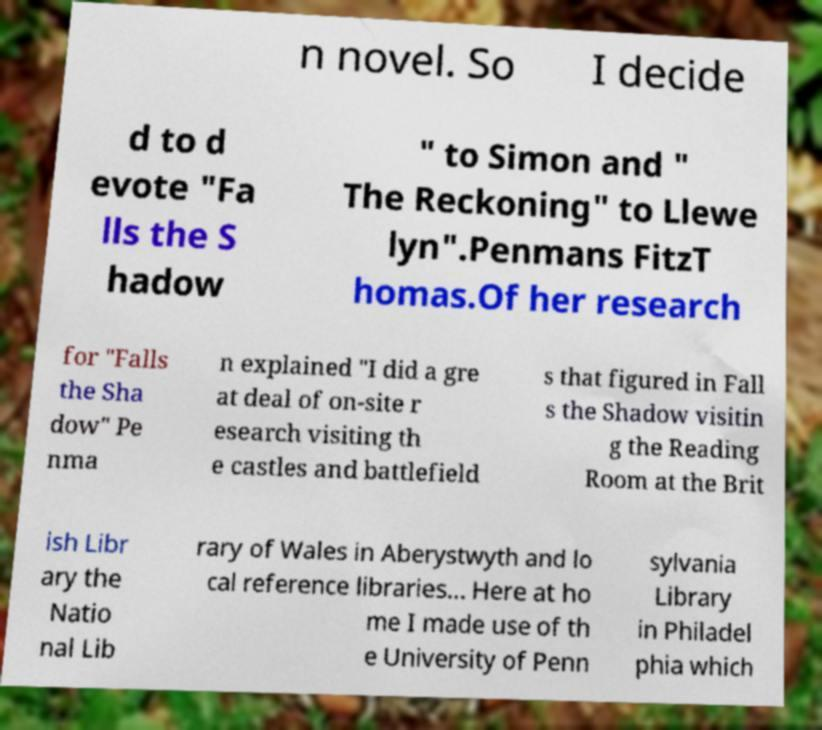What messages or text are displayed in this image? I need them in a readable, typed format. n novel. So I decide d to d evote "Fa lls the S hadow " to Simon and " The Reckoning" to Llewe lyn".Penmans FitzT homas.Of her research for "Falls the Sha dow" Pe nma n explained "I did a gre at deal of on-site r esearch visiting th e castles and battlefield s that figured in Fall s the Shadow visitin g the Reading Room at the Brit ish Libr ary the Natio nal Lib rary of Wales in Aberystwyth and lo cal reference libraries… Here at ho me I made use of th e University of Penn sylvania Library in Philadel phia which 